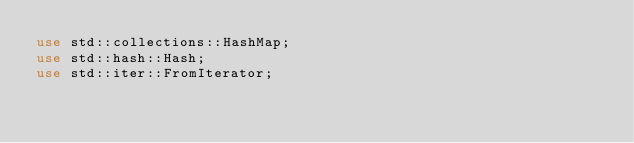<code> <loc_0><loc_0><loc_500><loc_500><_Rust_>use std::collections::HashMap;
use std::hash::Hash;
use std::iter::FromIterator;
</code> 